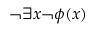<formula> <loc_0><loc_0><loc_500><loc_500>\neg \exists x \neg \phi ( x )</formula> 